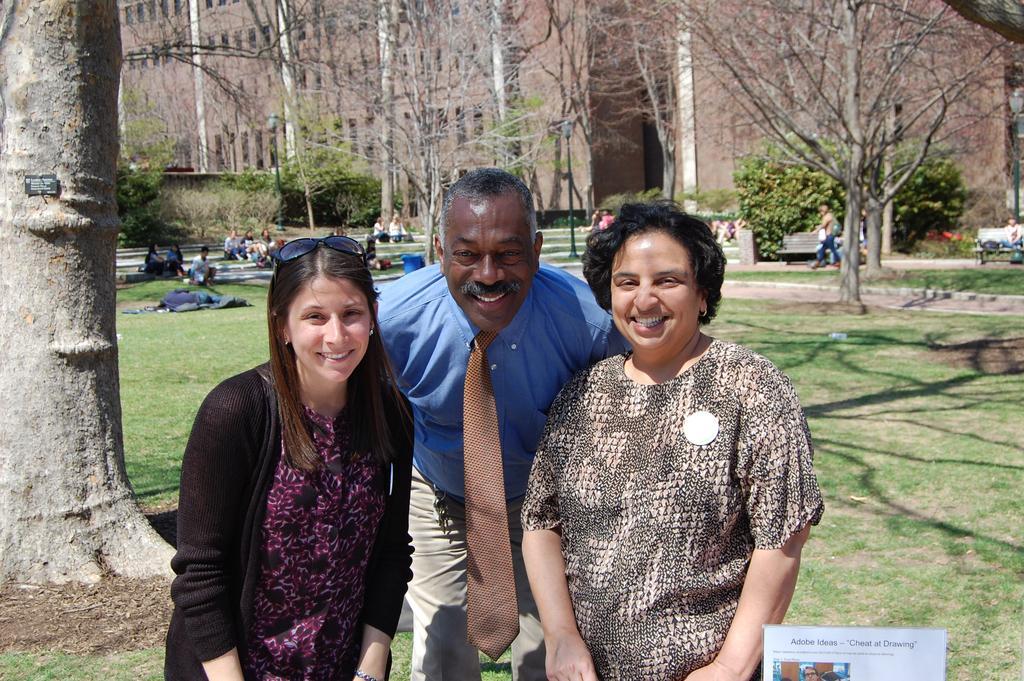How would you summarize this image in a sentence or two? In this image, at the middle we can see some people standing and they are smiling, in the background there is grass on the ground and there are some trees, there are some people sitting. 